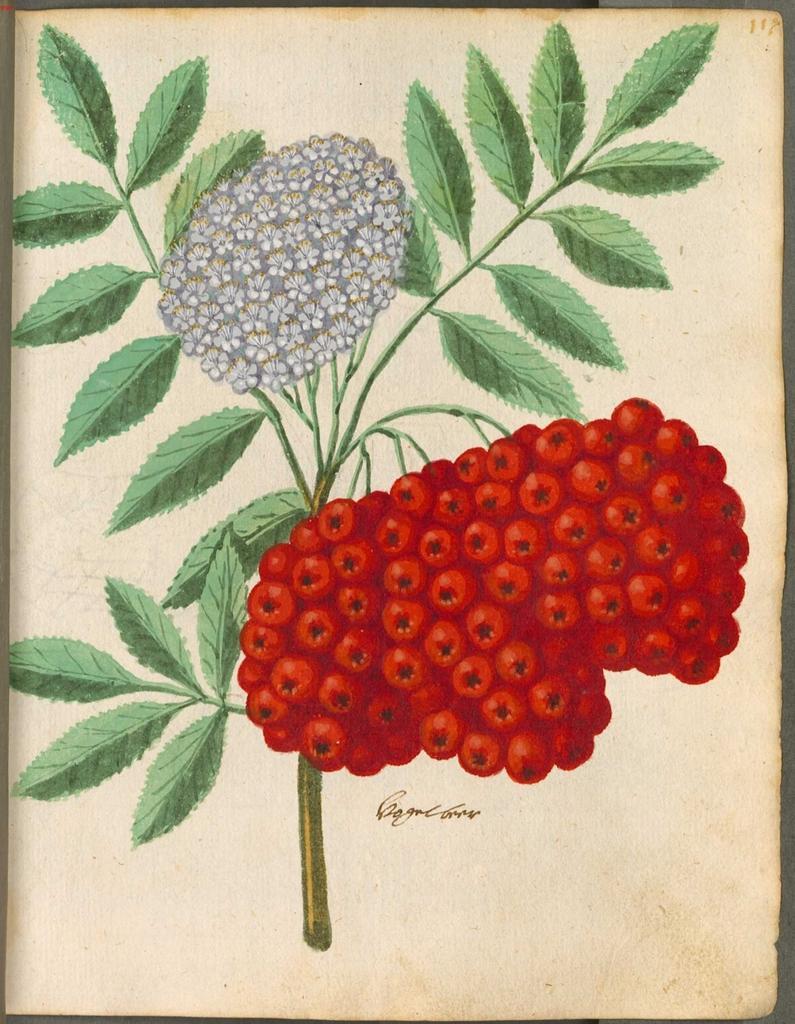In one or two sentences, can you explain what this image depicts? In this image we can see a paper on which we can see an art of green leaves, white colored flowers and red color fruits. Here we can see some text. 